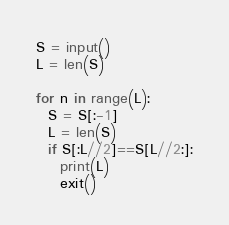<code> <loc_0><loc_0><loc_500><loc_500><_Python_>S = input()
L = len(S)
  
for n in range(L):
  S = S[:-1]
  L = len(S)
  if S[:L//2]==S[L//2:]:
    print(L)
    exit()</code> 